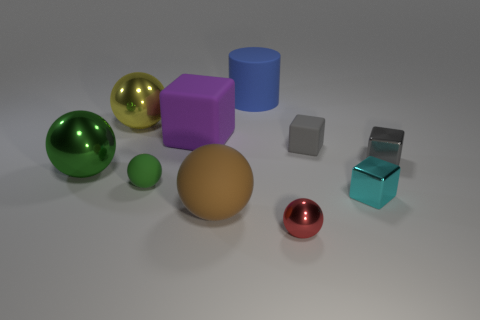Is the color of the large matte sphere the same as the large rubber cylinder?
Offer a terse response. No. There is a rubber block on the right side of the blue cylinder behind the small green rubber thing; what is its color?
Your answer should be compact. Gray. What number of tiny objects are brown rubber things or matte balls?
Your answer should be very brief. 1. The matte thing that is behind the cyan object and in front of the green metal object is what color?
Give a very brief answer. Green. Are the red thing and the brown ball made of the same material?
Ensure brevity in your answer.  No. What is the shape of the blue thing?
Keep it short and to the point. Cylinder. How many tiny gray metal things are on the left side of the green object that is left of the big sphere behind the gray metal block?
Provide a succinct answer. 0. What color is the other tiny shiny object that is the same shape as the yellow metallic object?
Provide a short and direct response. Red. There is a cyan shiny object that is left of the tiny gray object that is right of the rubber object that is on the right side of the small shiny ball; what is its shape?
Ensure brevity in your answer.  Cube. What size is the metal object that is both behind the cyan metallic object and right of the matte cylinder?
Provide a succinct answer. Small. 